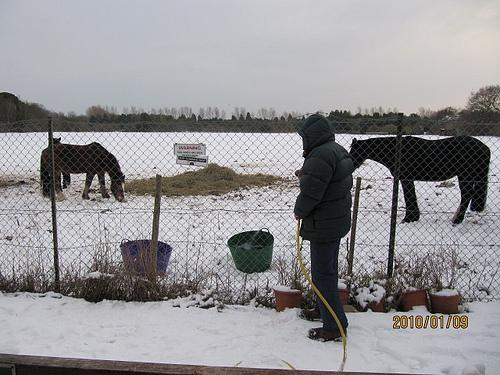What will happen to the water in the hose? freeze 